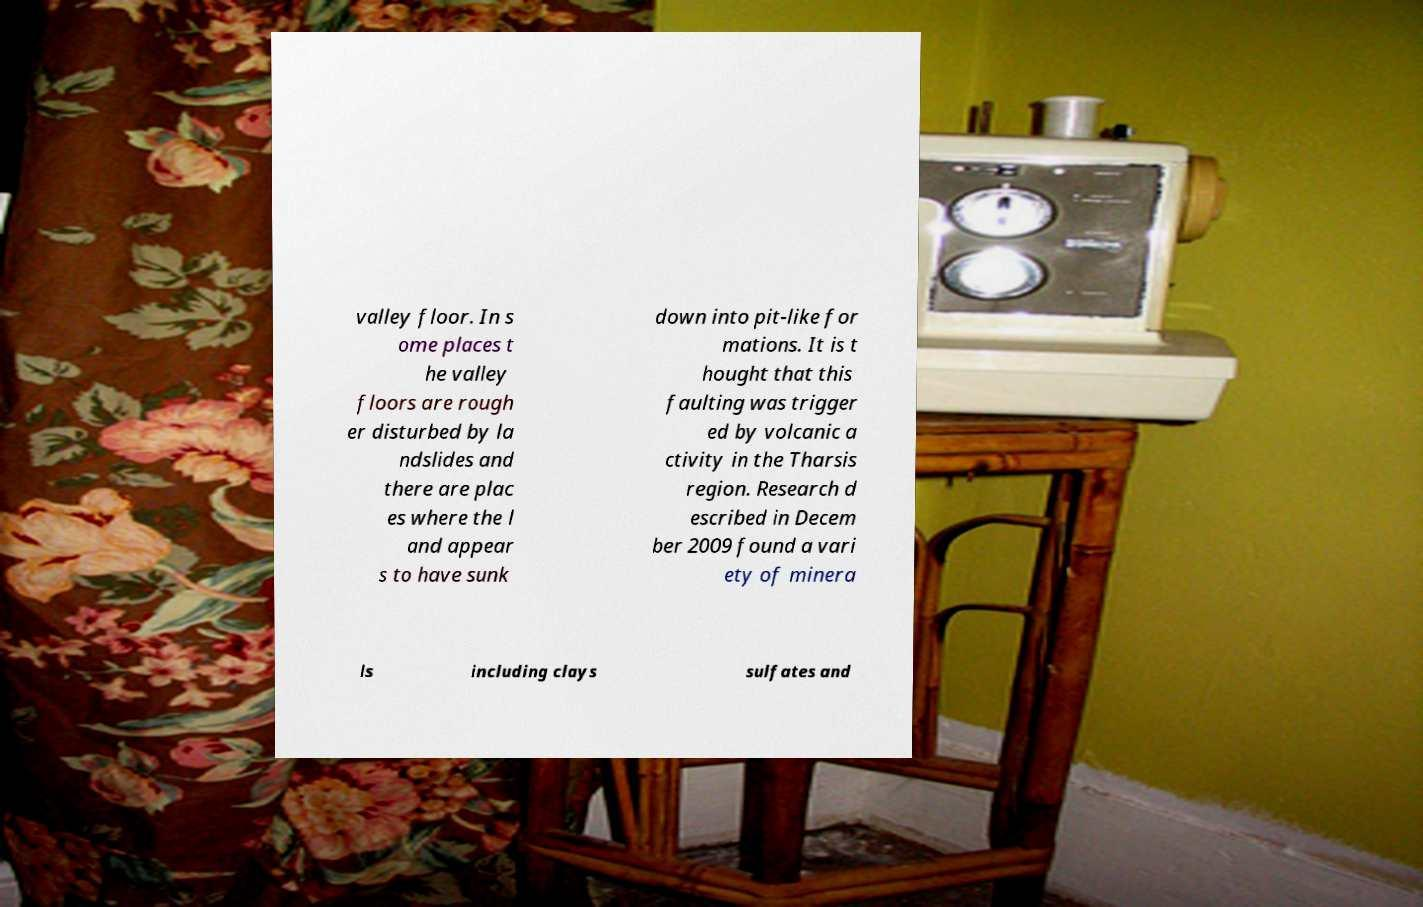Could you extract and type out the text from this image? valley floor. In s ome places t he valley floors are rough er disturbed by la ndslides and there are plac es where the l and appear s to have sunk down into pit-like for mations. It is t hought that this faulting was trigger ed by volcanic a ctivity in the Tharsis region. Research d escribed in Decem ber 2009 found a vari ety of minera ls including clays sulfates and 